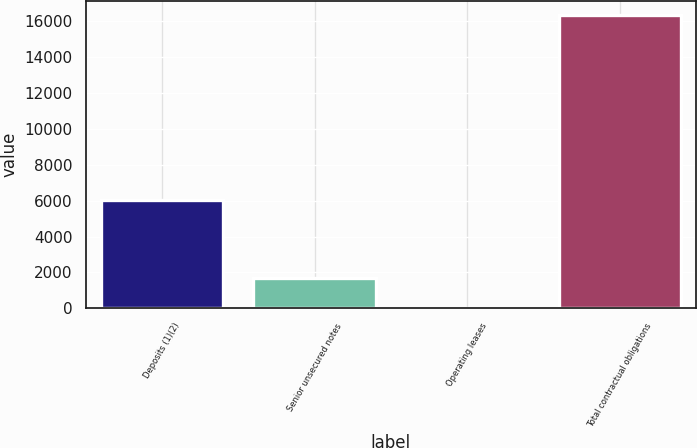Convert chart to OTSL. <chart><loc_0><loc_0><loc_500><loc_500><bar_chart><fcel>Deposits (1)(2)<fcel>Senior unsecured notes<fcel>Operating leases<fcel>Total contractual obligations<nl><fcel>6009<fcel>1671.9<fcel>45<fcel>16314<nl></chart> 